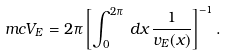Convert formula to latex. <formula><loc_0><loc_0><loc_500><loc_500>\ m c V _ { E } = 2 \pi \left [ \int _ { 0 } ^ { 2 \pi } \, d x \, \frac { 1 } { v _ { E } ( x ) } \right ] ^ { - 1 } .</formula> 